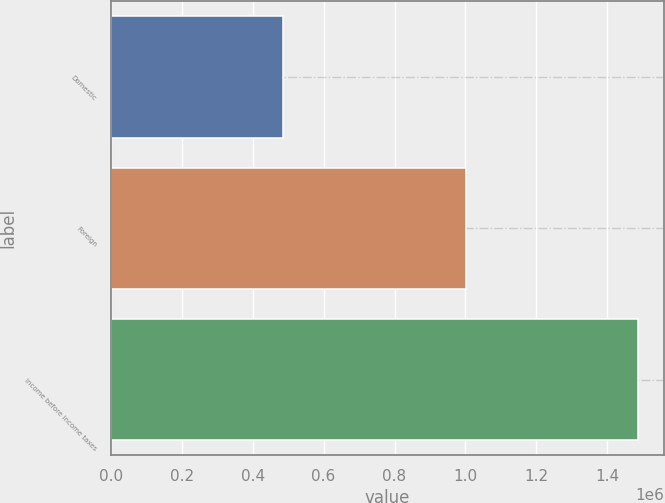Convert chart to OTSL. <chart><loc_0><loc_0><loc_500><loc_500><bar_chart><fcel>Domestic<fcel>Foreign<fcel>Income before income taxes<nl><fcel>484876<fcel>1.00085e+06<fcel>1.48573e+06<nl></chart> 